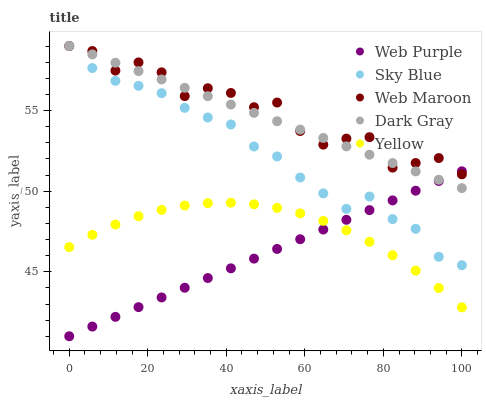Does Web Purple have the minimum area under the curve?
Answer yes or no. Yes. Does Web Maroon have the maximum area under the curve?
Answer yes or no. Yes. Does Sky Blue have the minimum area under the curve?
Answer yes or no. No. Does Sky Blue have the maximum area under the curve?
Answer yes or no. No. Is Dark Gray the smoothest?
Answer yes or no. Yes. Is Web Maroon the roughest?
Answer yes or no. Yes. Is Sky Blue the smoothest?
Answer yes or no. No. Is Sky Blue the roughest?
Answer yes or no. No. Does Web Purple have the lowest value?
Answer yes or no. Yes. Does Sky Blue have the lowest value?
Answer yes or no. No. Does Web Maroon have the highest value?
Answer yes or no. Yes. Does Sky Blue have the highest value?
Answer yes or no. No. Is Sky Blue less than Dark Gray?
Answer yes or no. Yes. Is Web Maroon greater than Yellow?
Answer yes or no. Yes. Does Web Maroon intersect Web Purple?
Answer yes or no. Yes. Is Web Maroon less than Web Purple?
Answer yes or no. No. Is Web Maroon greater than Web Purple?
Answer yes or no. No. Does Sky Blue intersect Dark Gray?
Answer yes or no. No. 